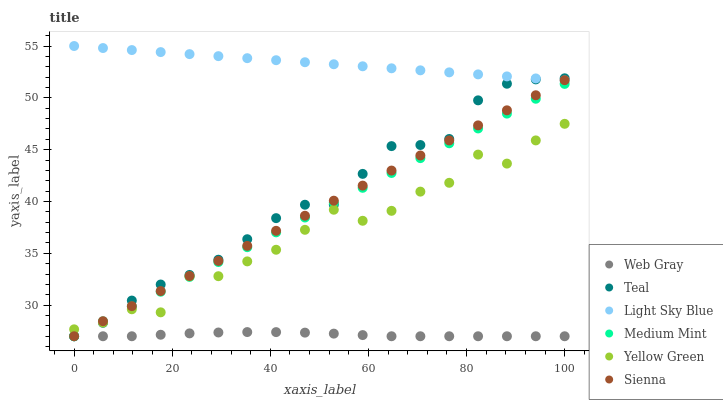Does Web Gray have the minimum area under the curve?
Answer yes or no. Yes. Does Light Sky Blue have the maximum area under the curve?
Answer yes or no. Yes. Does Yellow Green have the minimum area under the curve?
Answer yes or no. No. Does Yellow Green have the maximum area under the curve?
Answer yes or no. No. Is Light Sky Blue the smoothest?
Answer yes or no. Yes. Is Yellow Green the roughest?
Answer yes or no. Yes. Is Web Gray the smoothest?
Answer yes or no. No. Is Web Gray the roughest?
Answer yes or no. No. Does Medium Mint have the lowest value?
Answer yes or no. Yes. Does Yellow Green have the lowest value?
Answer yes or no. No. Does Light Sky Blue have the highest value?
Answer yes or no. Yes. Does Yellow Green have the highest value?
Answer yes or no. No. Is Web Gray less than Light Sky Blue?
Answer yes or no. Yes. Is Light Sky Blue greater than Medium Mint?
Answer yes or no. Yes. Does Light Sky Blue intersect Sienna?
Answer yes or no. Yes. Is Light Sky Blue less than Sienna?
Answer yes or no. No. Is Light Sky Blue greater than Sienna?
Answer yes or no. No. Does Web Gray intersect Light Sky Blue?
Answer yes or no. No. 